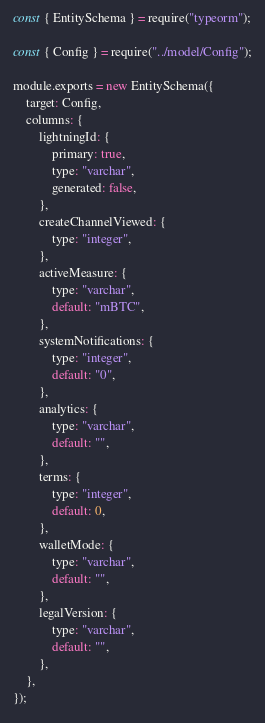<code> <loc_0><loc_0><loc_500><loc_500><_JavaScript_>const { EntitySchema } = require("typeorm");

const { Config } = require("../model/Config");

module.exports = new EntitySchema({
    target: Config,
    columns: {
        lightningId: {
            primary: true,
            type: "varchar",
            generated: false,
        },
        createChannelViewed: {
            type: "integer",
        },
        activeMeasure: {
            type: "varchar",
            default: "mBTC",
        },
        systemNotifications: {
            type: "integer",
            default: "0",
        },
        analytics: {
            type: "varchar",
            default: "",
        },
        terms: {
            type: "integer",
            default: 0,
        },
        walletMode: {
            type: "varchar",
            default: "",
        },
        legalVersion: {
            type: "varchar",
            default: "",
        },
    },
});
</code> 